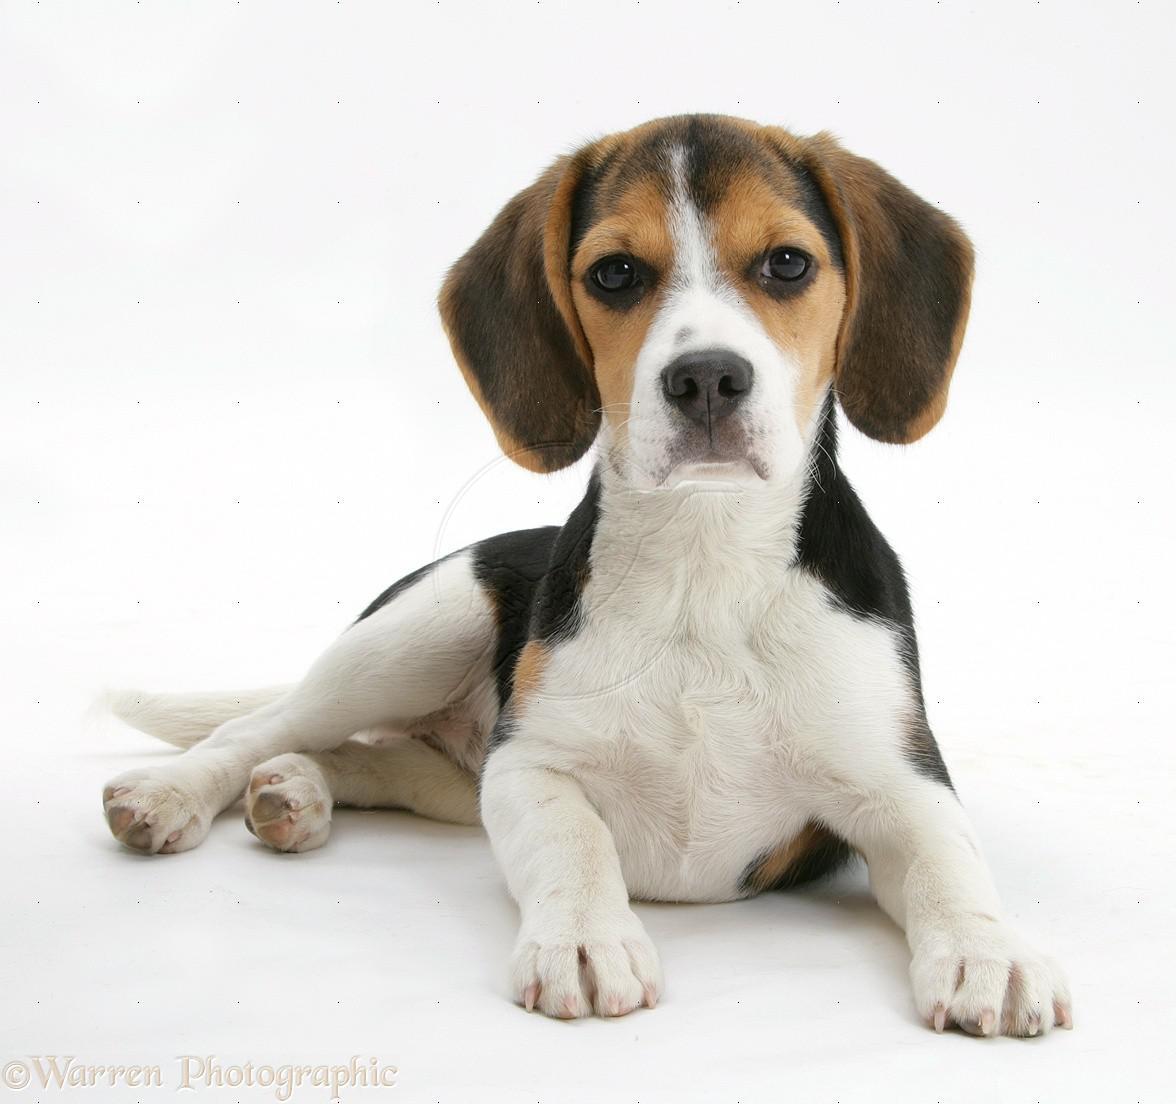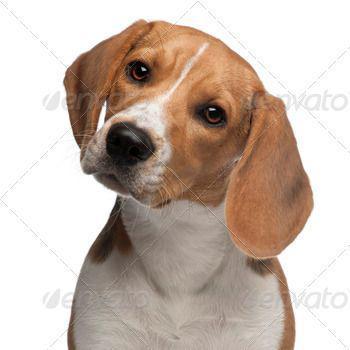The first image is the image on the left, the second image is the image on the right. Analyze the images presented: Is the assertion "Each image shows exactly one beagle, but the beagle on the right is older with a longer muzzle and is posed on an outdoor surface." valid? Answer yes or no. No. The first image is the image on the left, the second image is the image on the right. For the images displayed, is the sentence "The dog on the right is photographed in snow and has a white line going upwards from his nose to his forehead." factually correct? Answer yes or no. No. 